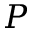<formula> <loc_0><loc_0><loc_500><loc_500>P</formula> 